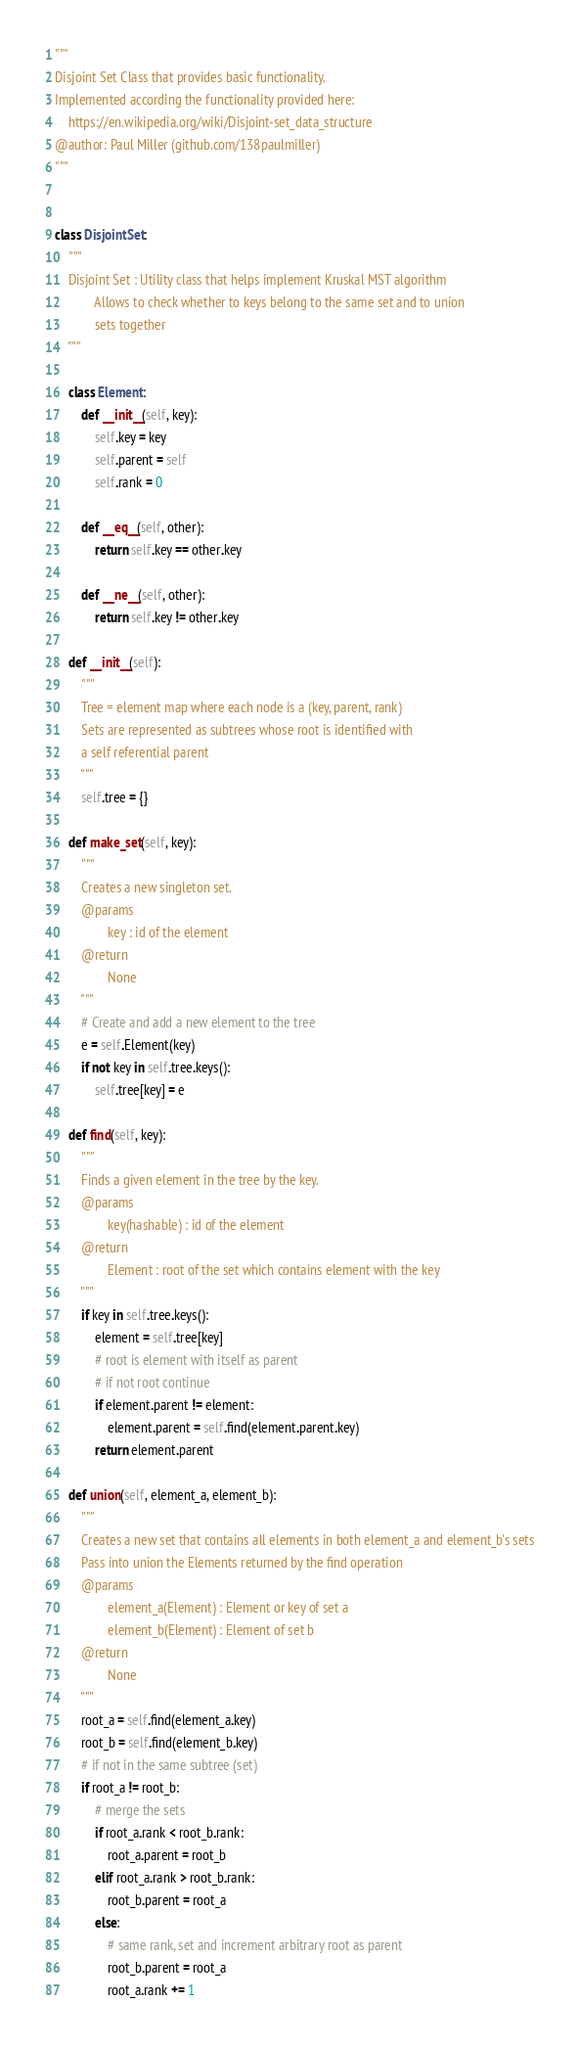Convert code to text. <code><loc_0><loc_0><loc_500><loc_500><_Python_>"""
Disjoint Set Class that provides basic functionality.
Implemented according the functionality provided here:
	https://en.wikipedia.org/wiki/Disjoint-set_data_structure
@author: Paul Miller (github.com/138paulmiller)
"""


class DisjointSet:
    """
    Disjoint Set : Utility class that helps implement Kruskal MST algorithm
            Allows to check whether to keys belong to the same set and to union
            sets together
    """

    class Element:
        def __init__(self, key):
            self.key = key
            self.parent = self
            self.rank = 0

        def __eq__(self, other):
            return self.key == other.key

        def __ne__(self, other):
            return self.key != other.key

    def __init__(self):
        """
        Tree = element map where each node is a (key, parent, rank)
        Sets are represented as subtrees whose root is identified with
        a self referential parent
        """
        self.tree = {}

    def make_set(self, key):
        """
        Creates a new singleton set.
        @params
                key : id of the element
        @return
                None
        """
        # Create and add a new element to the tree
        e = self.Element(key)
        if not key in self.tree.keys():
            self.tree[key] = e

    def find(self, key):
        """
        Finds a given element in the tree by the key.
        @params
                key(hashable) : id of the element
        @return
                Element : root of the set which contains element with the key
        """
        if key in self.tree.keys():
            element = self.tree[key]
            # root is element with itself as parent
            # if not root continue
            if element.parent != element:
                element.parent = self.find(element.parent.key)
            return element.parent

    def union(self, element_a, element_b):
        """
        Creates a new set that contains all elements in both element_a and element_b's sets
        Pass into union the Elements returned by the find operation
        @params
                element_a(Element) : Element or key of set a
                element_b(Element) : Element of set b
        @return
                None
        """
        root_a = self.find(element_a.key)
        root_b = self.find(element_b.key)
        # if not in the same subtree (set)
        if root_a != root_b:
            # merge the sets
            if root_a.rank < root_b.rank:
                root_a.parent = root_b
            elif root_a.rank > root_b.rank:
                root_b.parent = root_a
            else:
                # same rank, set and increment arbitrary root as parent
                root_b.parent = root_a
                root_a.rank += 1
</code> 